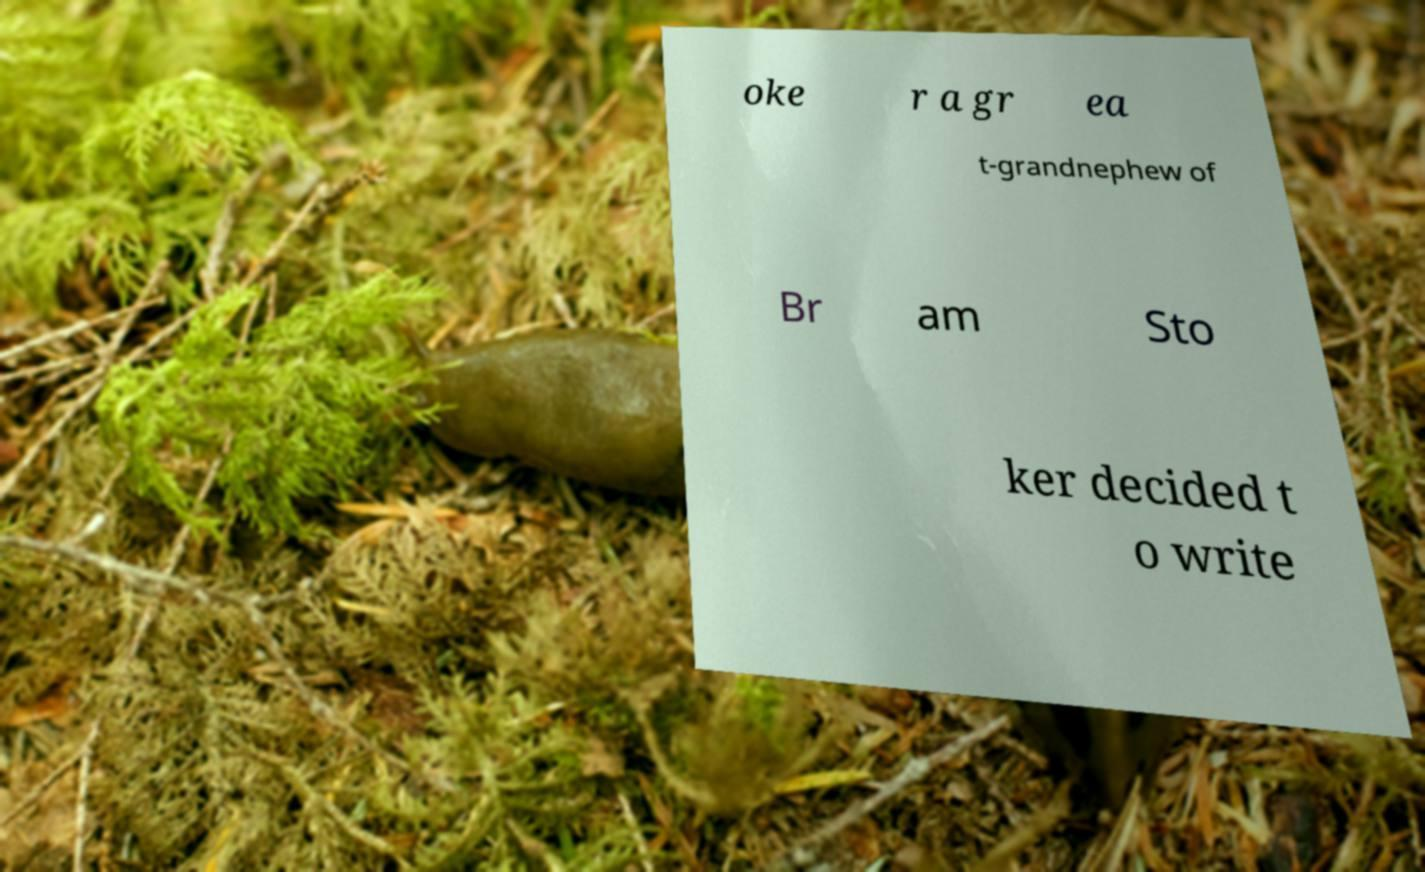Could you extract and type out the text from this image? oke r a gr ea t-grandnephew of Br am Sto ker decided t o write 